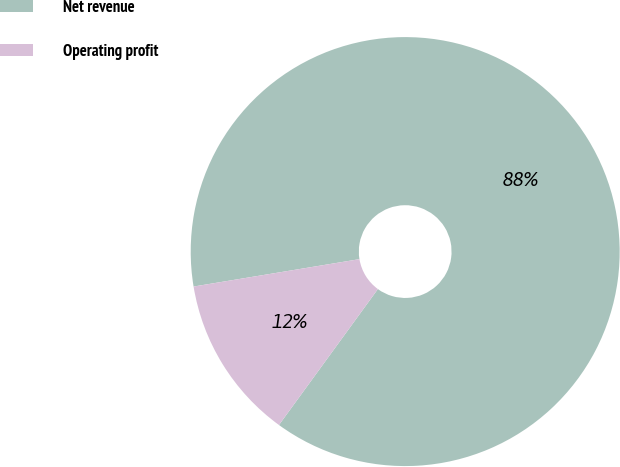Convert chart. <chart><loc_0><loc_0><loc_500><loc_500><pie_chart><fcel>Net revenue<fcel>Operating profit<nl><fcel>87.62%<fcel>12.38%<nl></chart> 